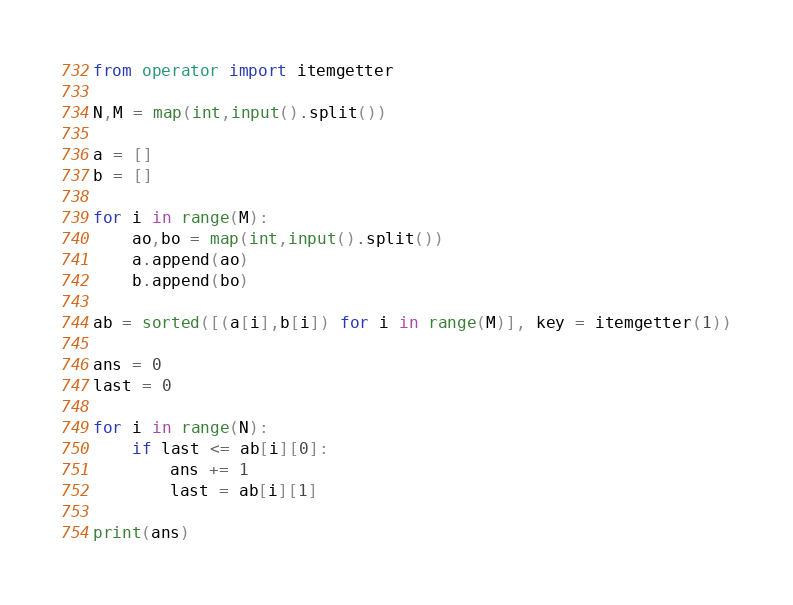Convert code to text. <code><loc_0><loc_0><loc_500><loc_500><_Python_>from operator import itemgetter

N,M = map(int,input().split())

a = []
b = []

for i in range(M):
    ao,bo = map(int,input().split())
    a.append(ao)
    b.append(bo)

ab = sorted([(a[i],b[i]) for i in range(M)], key = itemgetter(1))

ans = 0
last = 0

for i in range(N):
    if last <= ab[i][0]:
        ans += 1
        last = ab[i][1]

print(ans)
</code> 